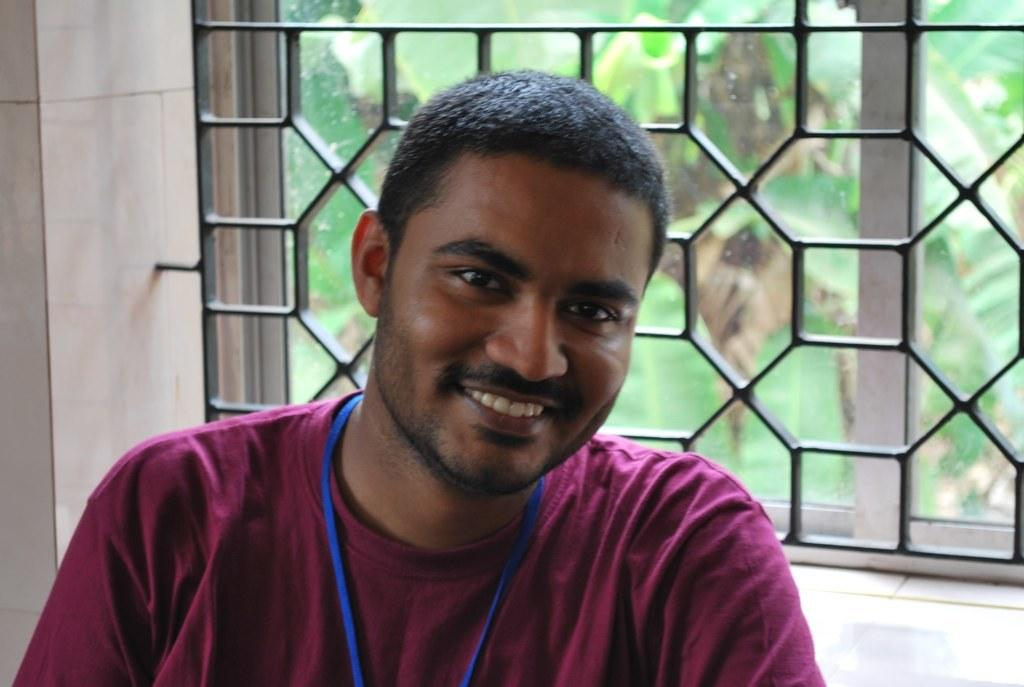Who or what is present in the image? There is a person in the image. What is the person doing or expressing? The person is smiling. What is located behind the person? There is a window behind the person. What can be seen through the window? Trees are visible through the window. What type of cake is being delivered through the window in the image? There is no cake or delivery in the image; it only features a person smiling with a window and trees visible through it. 